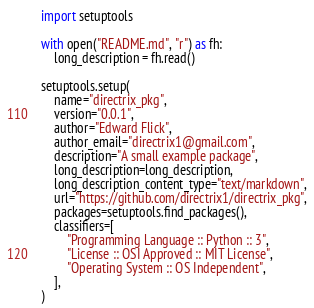Convert code to text. <code><loc_0><loc_0><loc_500><loc_500><_Python_>import setuptools

with open("README.md", "r") as fh:
    long_description = fh.read()

setuptools.setup(
    name="directrix_pkg",
    version="0.0.1",
    author="Edward Flick",
    author_email="directrix1@gmail.com",
    description="A small example package",
    long_description=long_description,
    long_description_content_type="text/markdown",
    url="https://github.com/directrix1/directrix_pkg",
    packages=setuptools.find_packages(),
    classifiers=[
        "Programming Language :: Python :: 3",
        "License :: OSI Approved :: MIT License",
        "Operating System :: OS Independent",
    ],
)
</code> 